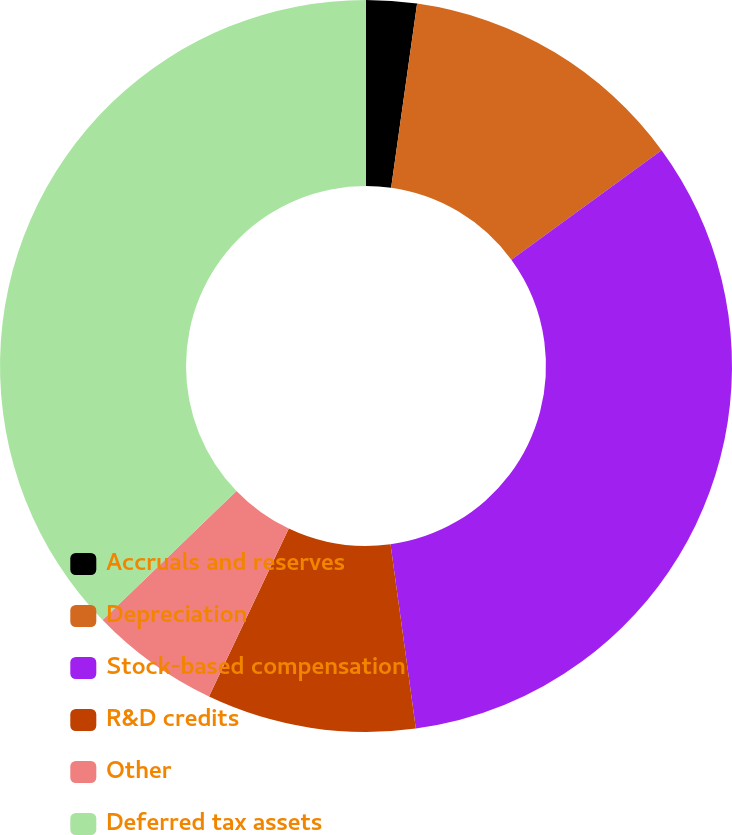Convert chart. <chart><loc_0><loc_0><loc_500><loc_500><pie_chart><fcel>Accruals and reserves<fcel>Depreciation<fcel>Stock-based compensation<fcel>R&D credits<fcel>Other<fcel>Deferred tax assets<nl><fcel>2.23%<fcel>12.73%<fcel>32.86%<fcel>9.23%<fcel>5.73%<fcel>37.21%<nl></chart> 